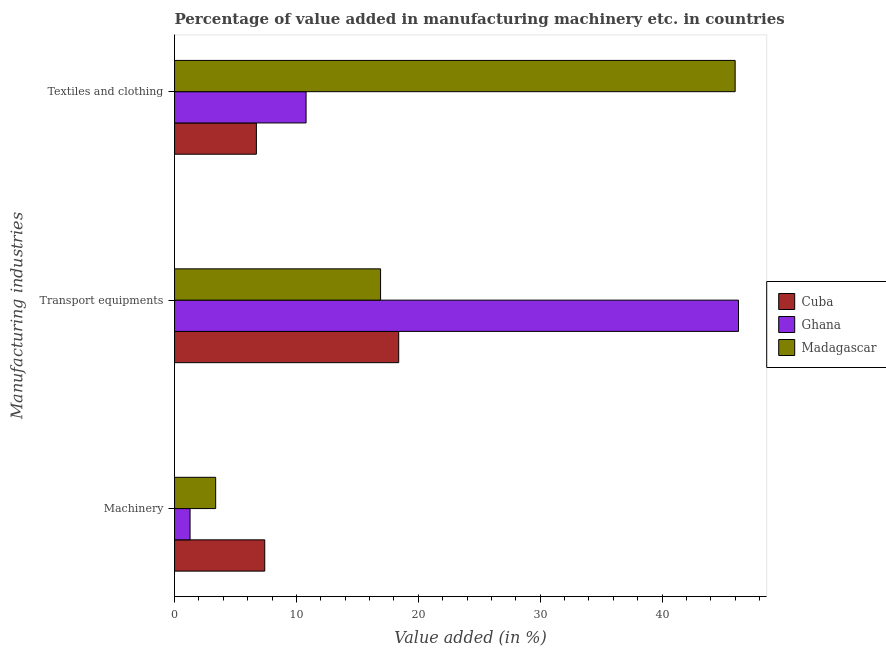How many different coloured bars are there?
Provide a short and direct response. 3. How many bars are there on the 3rd tick from the top?
Offer a terse response. 3. How many bars are there on the 1st tick from the bottom?
Offer a terse response. 3. What is the label of the 1st group of bars from the top?
Provide a short and direct response. Textiles and clothing. What is the value added in manufacturing machinery in Ghana?
Keep it short and to the point. 1.27. Across all countries, what is the maximum value added in manufacturing textile and clothing?
Your response must be concise. 45.99. Across all countries, what is the minimum value added in manufacturing textile and clothing?
Your response must be concise. 6.71. In which country was the value added in manufacturing machinery maximum?
Offer a terse response. Cuba. What is the total value added in manufacturing machinery in the graph?
Offer a very short reply. 12.05. What is the difference between the value added in manufacturing transport equipments in Cuba and that in Madagascar?
Ensure brevity in your answer.  1.49. What is the difference between the value added in manufacturing transport equipments in Cuba and the value added in manufacturing textile and clothing in Madagascar?
Your answer should be compact. -27.6. What is the average value added in manufacturing textile and clothing per country?
Offer a very short reply. 21.17. What is the difference between the value added in manufacturing transport equipments and value added in manufacturing textile and clothing in Madagascar?
Give a very brief answer. -29.09. In how many countries, is the value added in manufacturing transport equipments greater than 26 %?
Offer a very short reply. 1. What is the ratio of the value added in manufacturing machinery in Cuba to that in Ghana?
Provide a succinct answer. 5.81. Is the value added in manufacturing machinery in Ghana less than that in Madagascar?
Offer a very short reply. Yes. Is the difference between the value added in manufacturing textile and clothing in Cuba and Madagascar greater than the difference between the value added in manufacturing transport equipments in Cuba and Madagascar?
Offer a terse response. No. What is the difference between the highest and the second highest value added in manufacturing transport equipments?
Provide a short and direct response. 27.88. What is the difference between the highest and the lowest value added in manufacturing machinery?
Your answer should be compact. 6.13. In how many countries, is the value added in manufacturing textile and clothing greater than the average value added in manufacturing textile and clothing taken over all countries?
Provide a short and direct response. 1. What does the 3rd bar from the top in Textiles and clothing represents?
Provide a short and direct response. Cuba. What does the 2nd bar from the bottom in Textiles and clothing represents?
Offer a very short reply. Ghana. Are all the bars in the graph horizontal?
Offer a very short reply. Yes. What is the difference between two consecutive major ticks on the X-axis?
Give a very brief answer. 10. Are the values on the major ticks of X-axis written in scientific E-notation?
Your answer should be compact. No. Does the graph contain any zero values?
Give a very brief answer. No. How many legend labels are there?
Your response must be concise. 3. How are the legend labels stacked?
Your answer should be compact. Vertical. What is the title of the graph?
Make the answer very short. Percentage of value added in manufacturing machinery etc. in countries. What is the label or title of the X-axis?
Your response must be concise. Value added (in %). What is the label or title of the Y-axis?
Keep it short and to the point. Manufacturing industries. What is the Value added (in %) in Cuba in Machinery?
Provide a succinct answer. 7.4. What is the Value added (in %) in Ghana in Machinery?
Provide a succinct answer. 1.27. What is the Value added (in %) of Madagascar in Machinery?
Your response must be concise. 3.37. What is the Value added (in %) of Cuba in Transport equipments?
Keep it short and to the point. 18.39. What is the Value added (in %) of Ghana in Transport equipments?
Offer a terse response. 46.27. What is the Value added (in %) of Madagascar in Transport equipments?
Provide a succinct answer. 16.9. What is the Value added (in %) of Cuba in Textiles and clothing?
Provide a short and direct response. 6.71. What is the Value added (in %) in Ghana in Textiles and clothing?
Offer a very short reply. 10.79. What is the Value added (in %) of Madagascar in Textiles and clothing?
Give a very brief answer. 45.99. Across all Manufacturing industries, what is the maximum Value added (in %) of Cuba?
Keep it short and to the point. 18.39. Across all Manufacturing industries, what is the maximum Value added (in %) of Ghana?
Make the answer very short. 46.27. Across all Manufacturing industries, what is the maximum Value added (in %) in Madagascar?
Make the answer very short. 45.99. Across all Manufacturing industries, what is the minimum Value added (in %) in Cuba?
Ensure brevity in your answer.  6.71. Across all Manufacturing industries, what is the minimum Value added (in %) of Ghana?
Give a very brief answer. 1.27. Across all Manufacturing industries, what is the minimum Value added (in %) of Madagascar?
Provide a succinct answer. 3.37. What is the total Value added (in %) in Cuba in the graph?
Offer a terse response. 32.5. What is the total Value added (in %) in Ghana in the graph?
Your response must be concise. 58.33. What is the total Value added (in %) of Madagascar in the graph?
Provide a succinct answer. 66.27. What is the difference between the Value added (in %) in Cuba in Machinery and that in Transport equipments?
Give a very brief answer. -10.99. What is the difference between the Value added (in %) in Ghana in Machinery and that in Transport equipments?
Give a very brief answer. -44.99. What is the difference between the Value added (in %) of Madagascar in Machinery and that in Transport equipments?
Provide a short and direct response. -13.53. What is the difference between the Value added (in %) in Cuba in Machinery and that in Textiles and clothing?
Provide a short and direct response. 0.69. What is the difference between the Value added (in %) in Ghana in Machinery and that in Textiles and clothing?
Provide a succinct answer. -9.52. What is the difference between the Value added (in %) of Madagascar in Machinery and that in Textiles and clothing?
Provide a succinct answer. -42.62. What is the difference between the Value added (in %) in Cuba in Transport equipments and that in Textiles and clothing?
Make the answer very short. 11.68. What is the difference between the Value added (in %) of Ghana in Transport equipments and that in Textiles and clothing?
Keep it short and to the point. 35.48. What is the difference between the Value added (in %) in Madagascar in Transport equipments and that in Textiles and clothing?
Your answer should be compact. -29.09. What is the difference between the Value added (in %) of Cuba in Machinery and the Value added (in %) of Ghana in Transport equipments?
Ensure brevity in your answer.  -38.87. What is the difference between the Value added (in %) in Cuba in Machinery and the Value added (in %) in Madagascar in Transport equipments?
Provide a succinct answer. -9.5. What is the difference between the Value added (in %) of Ghana in Machinery and the Value added (in %) of Madagascar in Transport equipments?
Provide a short and direct response. -15.63. What is the difference between the Value added (in %) of Cuba in Machinery and the Value added (in %) of Ghana in Textiles and clothing?
Provide a short and direct response. -3.39. What is the difference between the Value added (in %) in Cuba in Machinery and the Value added (in %) in Madagascar in Textiles and clothing?
Your answer should be compact. -38.59. What is the difference between the Value added (in %) of Ghana in Machinery and the Value added (in %) of Madagascar in Textiles and clothing?
Make the answer very short. -44.72. What is the difference between the Value added (in %) in Cuba in Transport equipments and the Value added (in %) in Ghana in Textiles and clothing?
Make the answer very short. 7.6. What is the difference between the Value added (in %) in Cuba in Transport equipments and the Value added (in %) in Madagascar in Textiles and clothing?
Ensure brevity in your answer.  -27.6. What is the difference between the Value added (in %) in Ghana in Transport equipments and the Value added (in %) in Madagascar in Textiles and clothing?
Offer a very short reply. 0.27. What is the average Value added (in %) of Cuba per Manufacturing industries?
Your answer should be compact. 10.83. What is the average Value added (in %) in Ghana per Manufacturing industries?
Provide a succinct answer. 19.44. What is the average Value added (in %) of Madagascar per Manufacturing industries?
Give a very brief answer. 22.09. What is the difference between the Value added (in %) of Cuba and Value added (in %) of Ghana in Machinery?
Your answer should be compact. 6.13. What is the difference between the Value added (in %) in Cuba and Value added (in %) in Madagascar in Machinery?
Your answer should be very brief. 4.03. What is the difference between the Value added (in %) of Ghana and Value added (in %) of Madagascar in Machinery?
Provide a succinct answer. -2.1. What is the difference between the Value added (in %) of Cuba and Value added (in %) of Ghana in Transport equipments?
Your response must be concise. -27.88. What is the difference between the Value added (in %) of Cuba and Value added (in %) of Madagascar in Transport equipments?
Ensure brevity in your answer.  1.49. What is the difference between the Value added (in %) of Ghana and Value added (in %) of Madagascar in Transport equipments?
Give a very brief answer. 29.36. What is the difference between the Value added (in %) of Cuba and Value added (in %) of Ghana in Textiles and clothing?
Provide a succinct answer. -4.08. What is the difference between the Value added (in %) of Cuba and Value added (in %) of Madagascar in Textiles and clothing?
Offer a terse response. -39.28. What is the difference between the Value added (in %) of Ghana and Value added (in %) of Madagascar in Textiles and clothing?
Ensure brevity in your answer.  -35.2. What is the ratio of the Value added (in %) in Cuba in Machinery to that in Transport equipments?
Make the answer very short. 0.4. What is the ratio of the Value added (in %) of Ghana in Machinery to that in Transport equipments?
Keep it short and to the point. 0.03. What is the ratio of the Value added (in %) in Madagascar in Machinery to that in Transport equipments?
Provide a short and direct response. 0.2. What is the ratio of the Value added (in %) in Cuba in Machinery to that in Textiles and clothing?
Make the answer very short. 1.1. What is the ratio of the Value added (in %) in Ghana in Machinery to that in Textiles and clothing?
Provide a succinct answer. 0.12. What is the ratio of the Value added (in %) of Madagascar in Machinery to that in Textiles and clothing?
Ensure brevity in your answer.  0.07. What is the ratio of the Value added (in %) in Cuba in Transport equipments to that in Textiles and clothing?
Your answer should be compact. 2.74. What is the ratio of the Value added (in %) of Ghana in Transport equipments to that in Textiles and clothing?
Offer a very short reply. 4.29. What is the ratio of the Value added (in %) of Madagascar in Transport equipments to that in Textiles and clothing?
Offer a very short reply. 0.37. What is the difference between the highest and the second highest Value added (in %) in Cuba?
Provide a succinct answer. 10.99. What is the difference between the highest and the second highest Value added (in %) in Ghana?
Keep it short and to the point. 35.48. What is the difference between the highest and the second highest Value added (in %) of Madagascar?
Offer a terse response. 29.09. What is the difference between the highest and the lowest Value added (in %) in Cuba?
Give a very brief answer. 11.68. What is the difference between the highest and the lowest Value added (in %) of Ghana?
Keep it short and to the point. 44.99. What is the difference between the highest and the lowest Value added (in %) of Madagascar?
Provide a short and direct response. 42.62. 